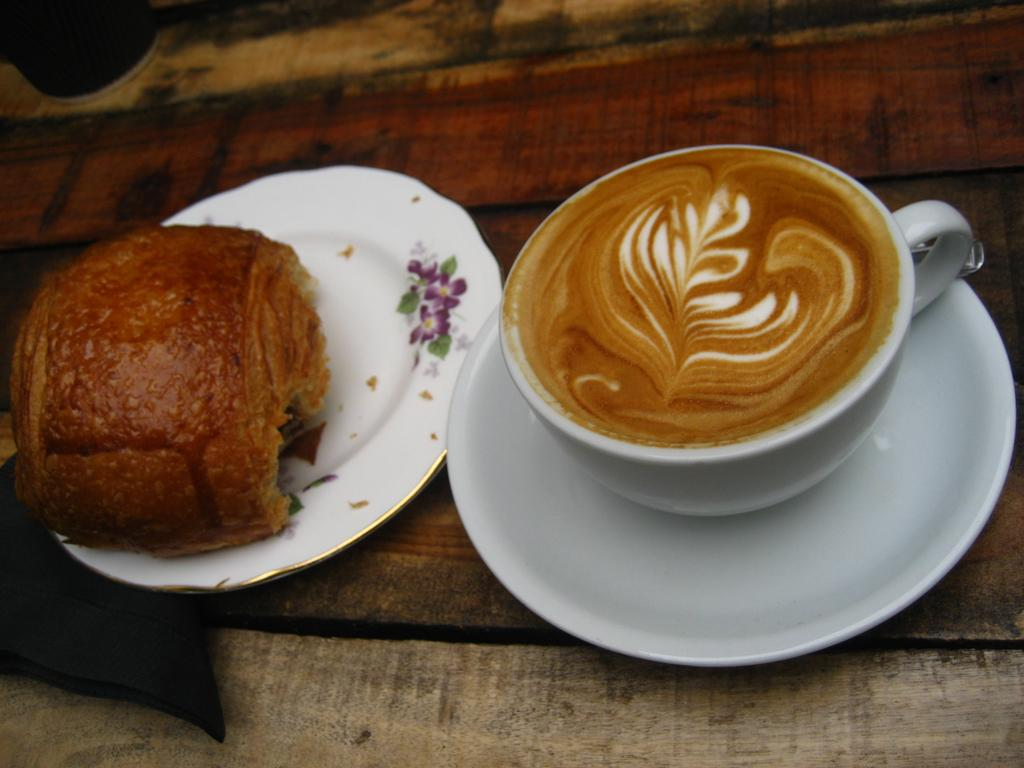What is in the cup that is visible in the image? There is coffee in a cup in the image. What is the saucer used for in the image? The saucer is likely used to hold the cup of coffee. What type of food is on the plate in the image? The image only mentions that there is food on a plate, but the specific type of food is not specified. What is the unspecified object in the image? The facts do not provide any details about the unspecified object, so we cannot describe it. Where is the scene in the image set? The image appears to be set on a table. Can you see a robin playing with the soup in the image? There is no soup or robin present in the image. What type of play is depicted in the image? There is no play or any indication of play in the image. 